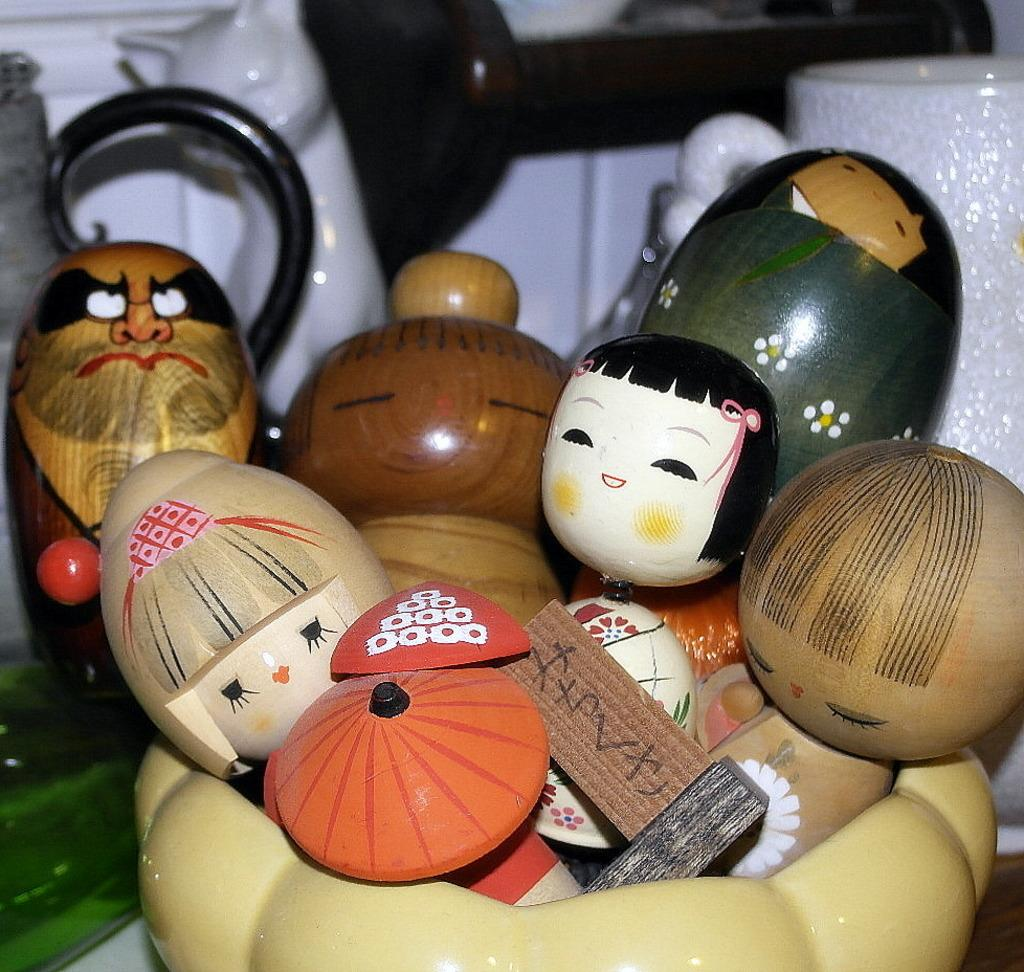What is located in the center of the image? There is a bowl in the center of the image. What is inside the bowl? The bowl contains toys. Can you describe any other objects visible in the background of the image? There is a cup in the background of the image, and there are other objects visible as well. What type of leather material can be seen being used to write with in the image? There is no leather material or writing instrument present in the image. How does the pencil self-sharpen itself in the image? There is no pencil or self-sharpening mechanism present in the image. 